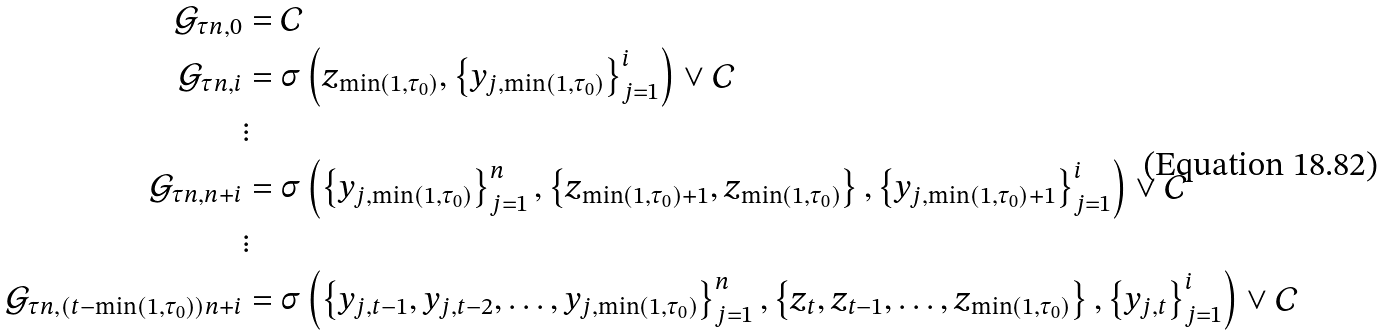<formula> <loc_0><loc_0><loc_500><loc_500>\mathcal { G } _ { \tau n , 0 } & = \mathcal { C } \\ \mathcal { G } _ { \tau n , i } & = \sigma \left ( z _ { \min \left ( 1 , \tau _ { 0 } \right ) } , \left \{ y _ { j , \min \left ( 1 , \tau _ { 0 } \right ) } \right \} _ { j = 1 } ^ { i } \right ) \vee \mathcal { C } \\ & \vdots \\ \mathcal { G } _ { \tau n , n + i } & = \sigma \left ( \left \{ y _ { j , \min \left ( 1 , \tau _ { 0 } \right ) } \right \} _ { j = 1 } ^ { n } , \left \{ z _ { \min \left ( 1 , \tau _ { 0 } \right ) + 1 } , z _ { \min \left ( 1 , \tau _ { 0 } \right ) } \right \} , \left \{ y _ { j , \min \left ( 1 , \tau _ { 0 } \right ) + 1 } \right \} _ { j = 1 } ^ { i } \right ) \vee \mathcal { C } \\ & \vdots \\ \mathcal { G } _ { \tau n , \left ( t - \min \left ( 1 , \tau _ { 0 } \right ) \right ) n + i } & = \sigma \left ( \left \{ y _ { j , t - 1 } , y _ { j , t - 2 } , \dots , y _ { j , \min \left ( 1 , \tau _ { 0 } \right ) } \right \} _ { j = 1 } ^ { n } , \left \{ z _ { t } , z _ { t - 1 } , \dots , z _ { \min \left ( 1 , \tau _ { 0 } \right ) } \right \} , \left \{ y _ { j , t } \right \} _ { j = 1 } ^ { i } \right ) \vee \mathcal { C }</formula> 